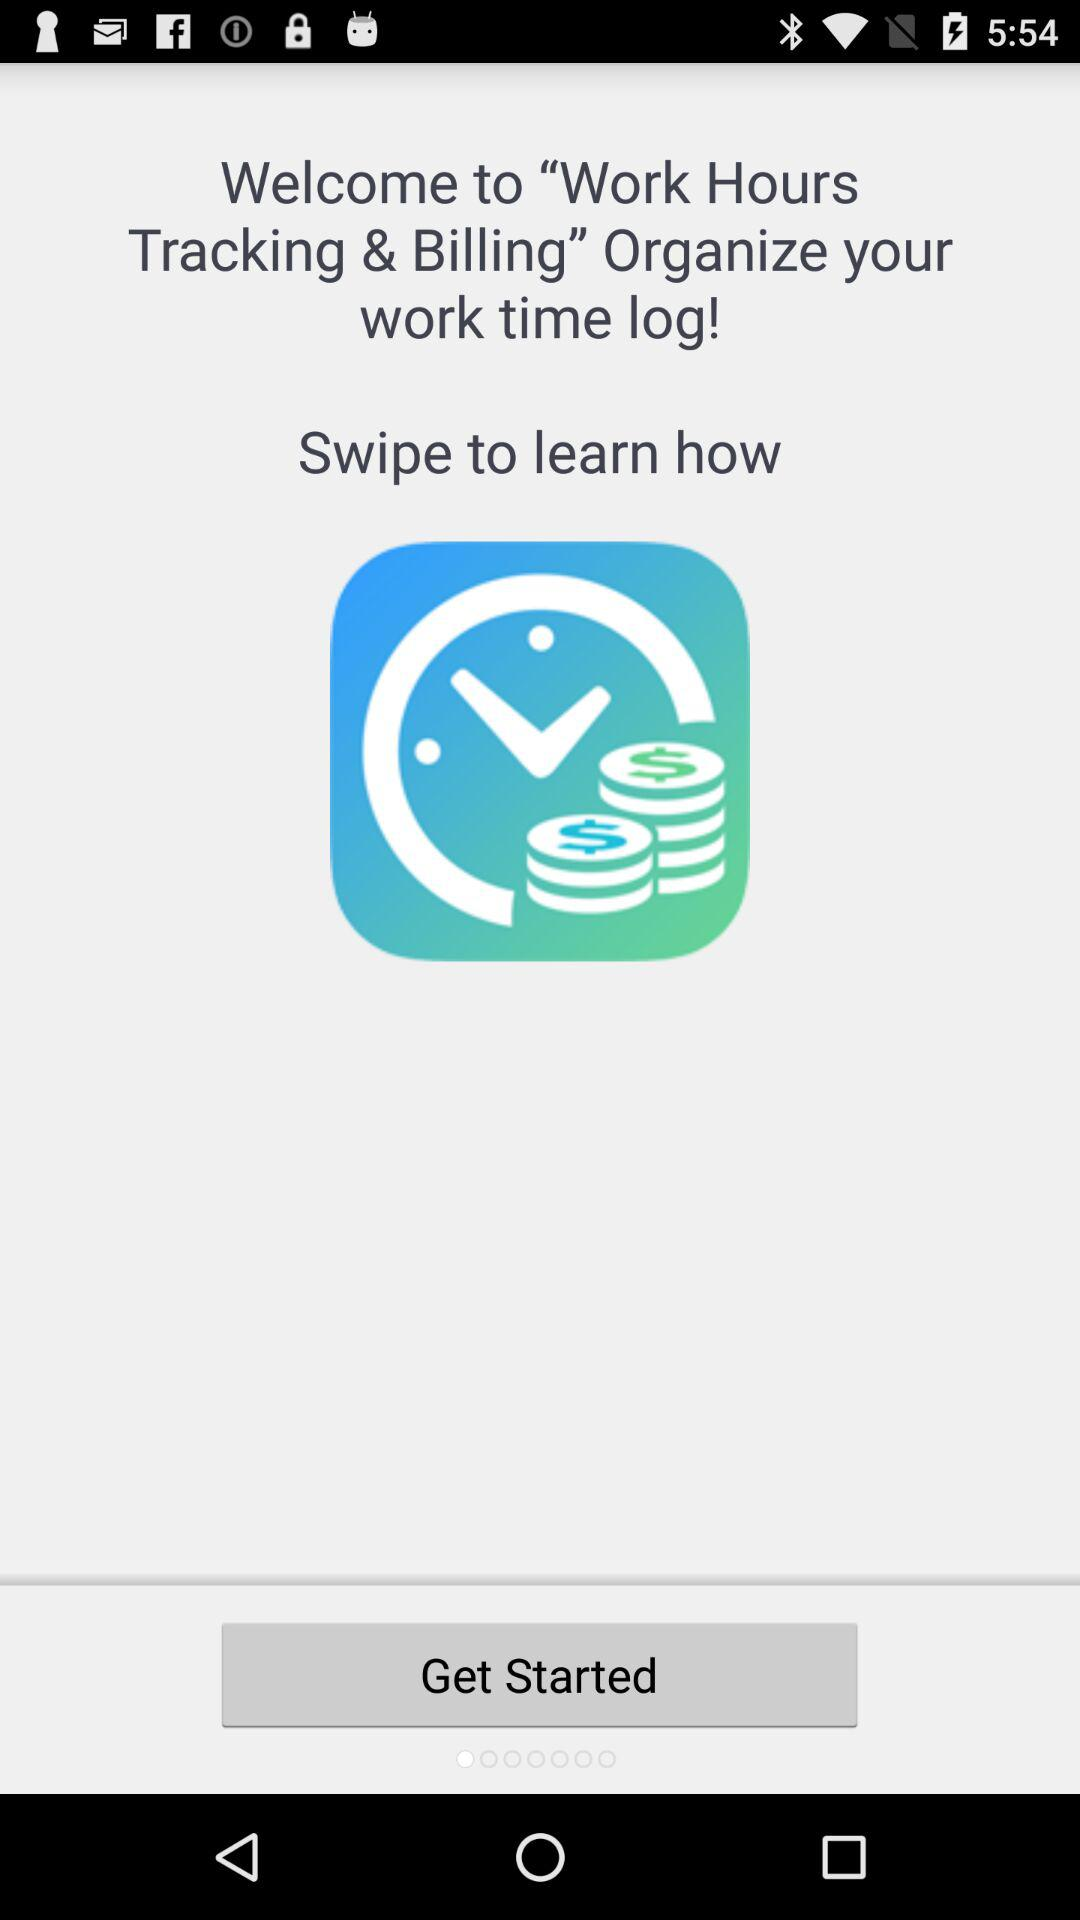What version of "Work Hours Tracking & Billing" is this?
When the provided information is insufficient, respond with <no answer>. <no answer> 